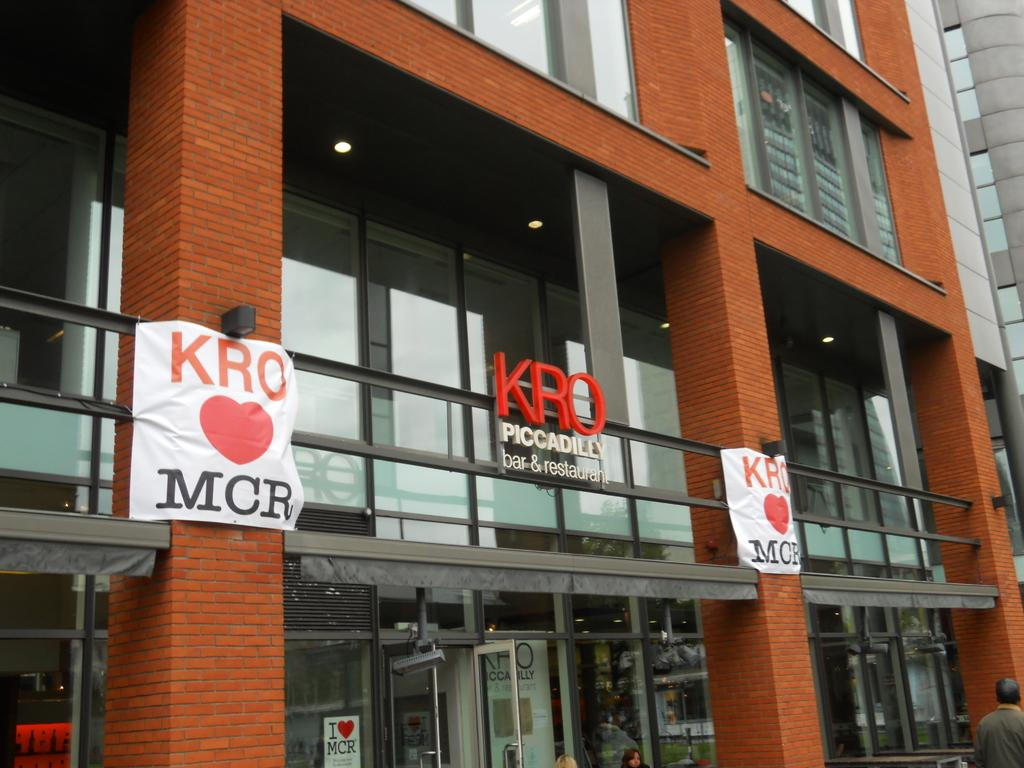What is the main structure in the center of the image? There is a building in the center of the image. What can be seen on the left side of the building? There are posters on the left side of the building. What can be seen on the right side of the building? There are posters on the right side of the building. Where is the entrance to the building located? There is a door at the bottom of the image. Are there any people near the entrance? Yes, there are persons near the door. Who is the creator of the posters in the image? The image does not provide information about the creator of the posters. What type of throat medicine is being handed out to the persons near the door? There is no indication of any throat medicine or medical activity in the image. 